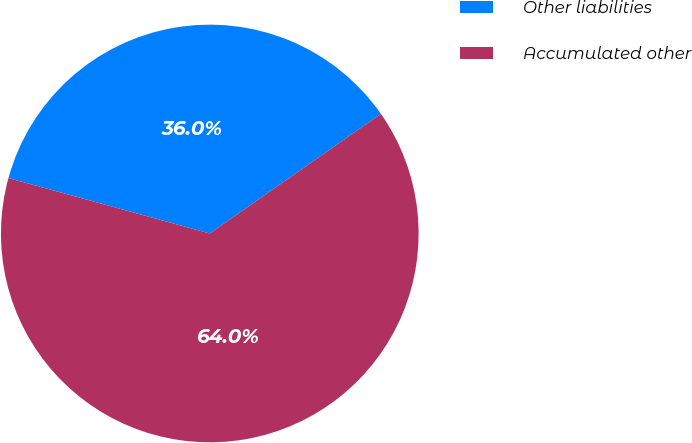Convert chart. <chart><loc_0><loc_0><loc_500><loc_500><pie_chart><fcel>Other liabilities<fcel>Accumulated other<nl><fcel>36.01%<fcel>63.99%<nl></chart> 